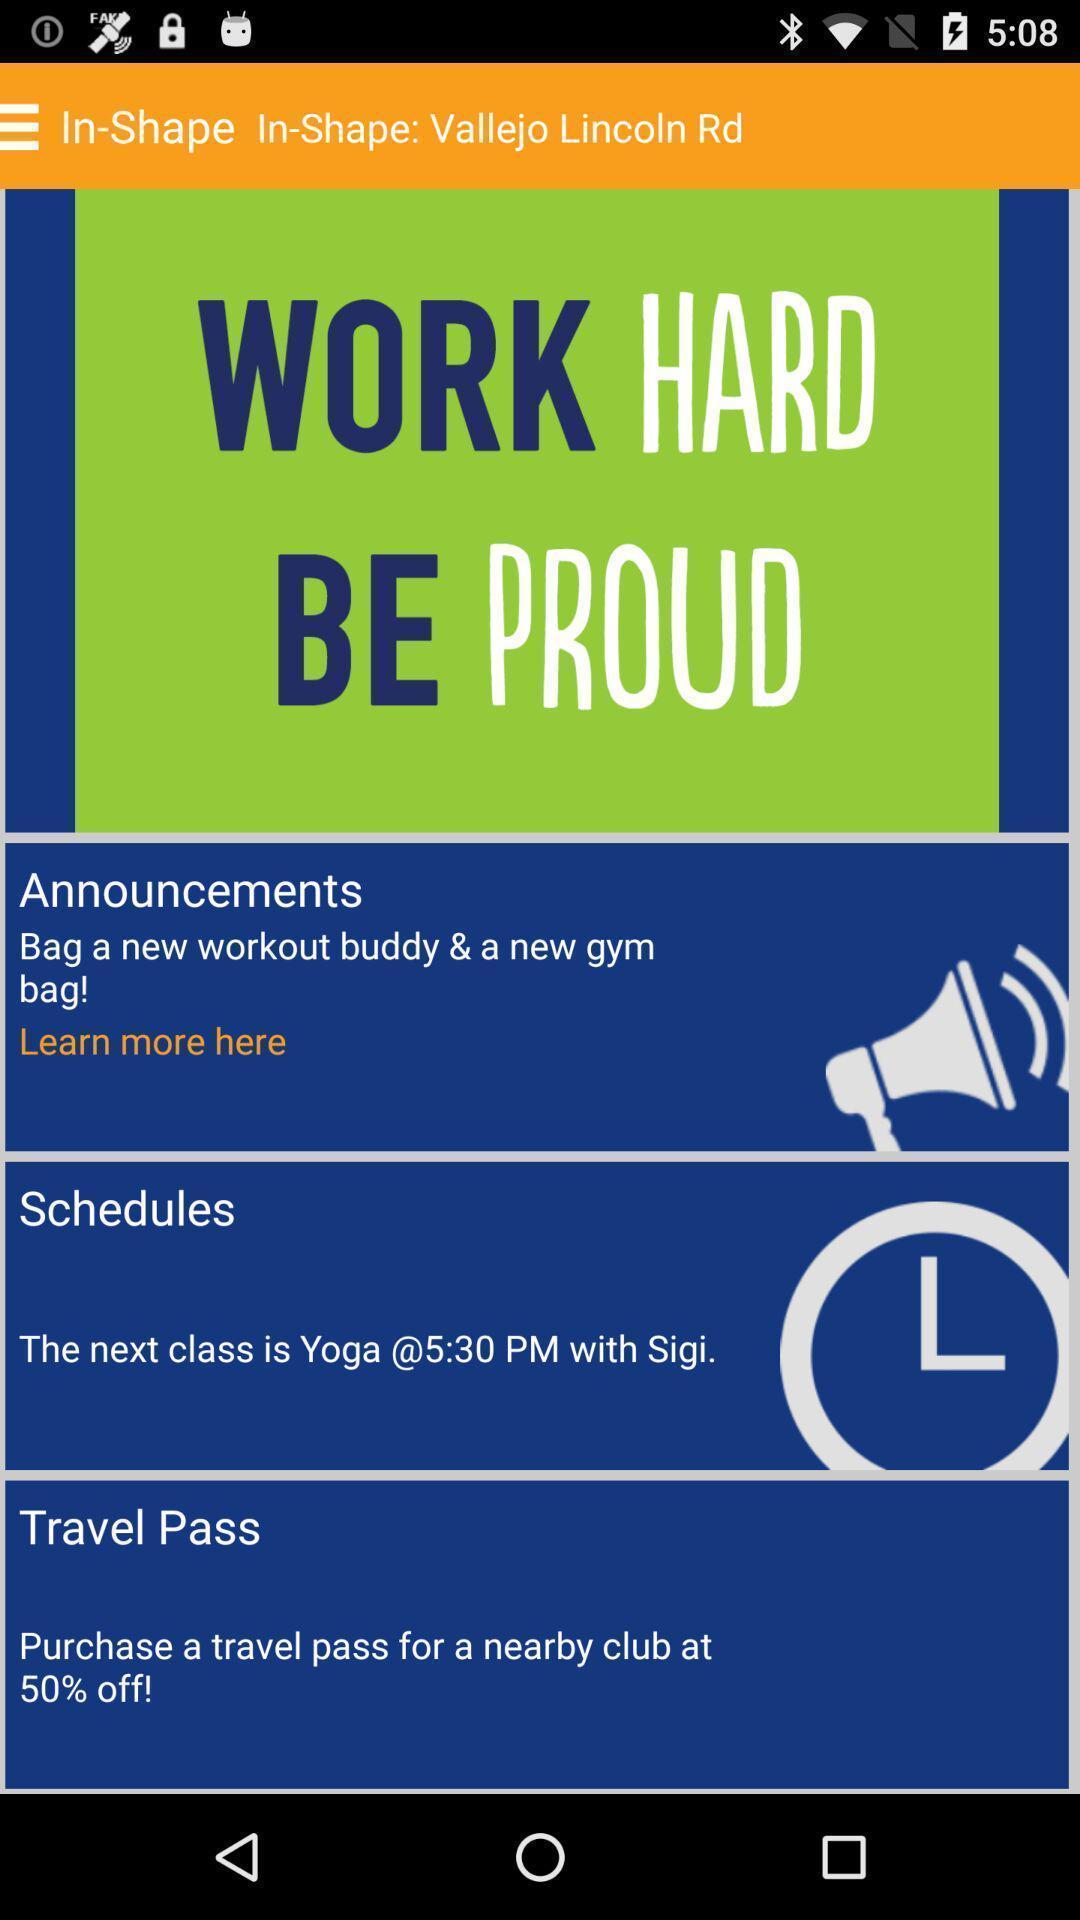Provide a textual representation of this image. Page showing multiple options. 